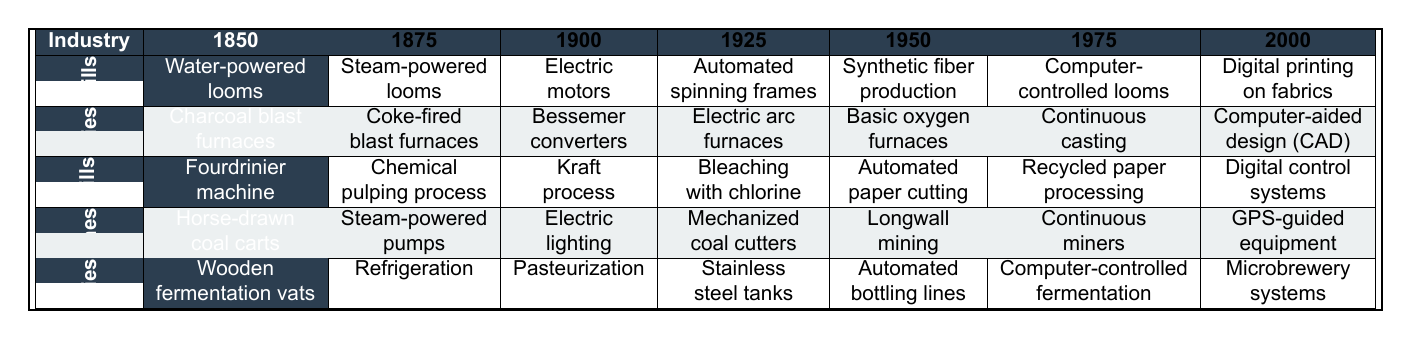What technological advancement did textile mills adopt in 1900? In the 'Textile Mills' row under the year 1900, the adoption of 'Electric motors' is stated.
Answer: Electric motors Which industry first adopted mechanized coal cutters and in what year? Looking at the 'Coal Mines' row, it shows that 'Mechanized coal cutters' were adopted in the year 1925.
Answer: 1925 Did breweries adopt stainless steel tanks before or after 1950? The 'Breweries' row shows that 'Stainless steel tanks' were adopted in 1925, which is before 1950.
Answer: Before Which advancement was adopted in paper mills in 1975? In the 'Paper Mills' row for 1975, 'Recycled paper processing' is listed as the advancement adopted.
Answer: Recycled paper processing What is the last technological advancement adopted by iron foundries, and in what year? The last technological advancement listed for 'Iron Foundries' is 'Computer-aided design (CAD)', which was adopted in 2000.
Answer: Computer-aided design (CAD) in 2000 How many distinct technological advancements did the coal mines adopt by the year 2000? Counting the rows under 'Coal Mines', there are seven distinct advancements listed up to the year 2000.
Answer: Seven Which industry transitioned to digital systems last, according to the table? Observing the last advancements under each industry, 'Microbrewery systems' in breweries in 2000 is the last, followed by digital systems in textile and paper mills, which were adopted earlier.
Answer: Breweries Was electric lighting adopted in coal mines before or after 1925? The row for 'Coal Mines' indicates that 'Electric lighting' was adopted in 1900, which is before 1925.
Answer: Before Identify which industry adopted the production of synthetic fibers and in which year. The 'Textile Mills' row indicates that 'Synthetic fiber production' was adopted in 1950.
Answer: Textile Mills in 1950 What advancements were introduced in paper mills in the 1925 timeframe? Referring to the 'Paper Mills' row for the year 1925, it lists 'Bleaching with chlorine' as the advancement introduced.
Answer: Bleaching with chlorine How do the numbers of advancements compare between iron foundries and textile mills? The 'Iron Foundries' and 'Textile Mills' both show seven advancements each. Therefore, the number is equal.
Answer: Equal What is the technological progression chronological order for breweries? The 'Breweries' row lists advancements chronologically as: Wooden fermentation vats (1850), Refrigeration (1875), Pasteurization (1900), Stainless steel tanks (1925), Automated bottling lines (1975), Computer-controlled fermentation (2000), and Microbrewery systems (2000).
Answer: 1850 to 2000 